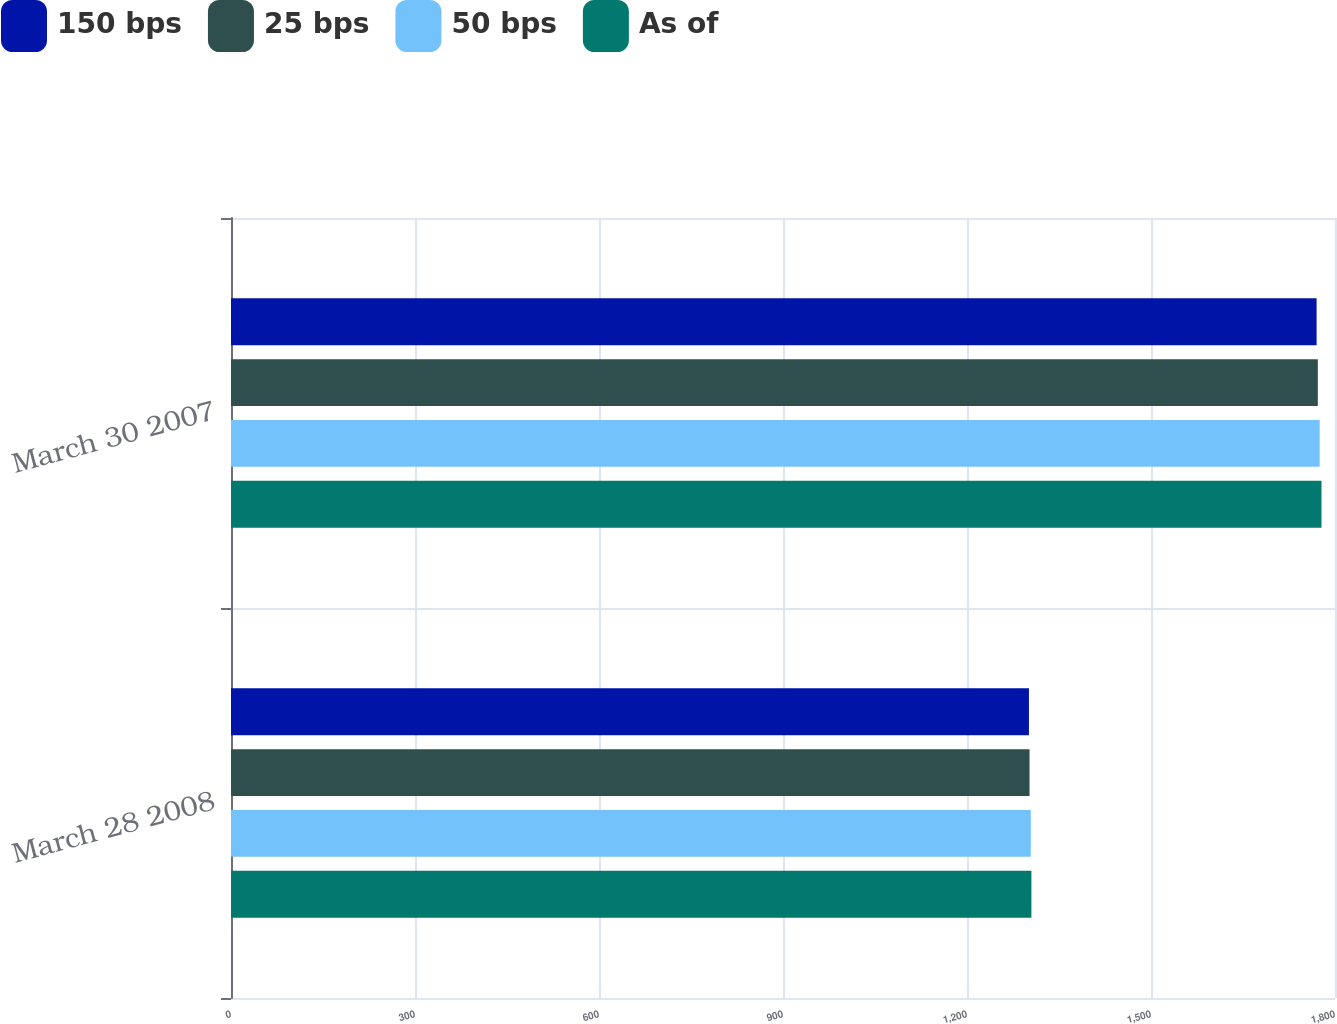Convert chart. <chart><loc_0><loc_0><loc_500><loc_500><stacked_bar_chart><ecel><fcel>March 28 2008<fcel>March 30 2007<nl><fcel>150 bps<fcel>1301<fcel>1770<nl><fcel>25 bps<fcel>1302<fcel>1772<nl><fcel>50 bps<fcel>1304<fcel>1775<nl><fcel>As of<fcel>1305<fcel>1778<nl></chart> 